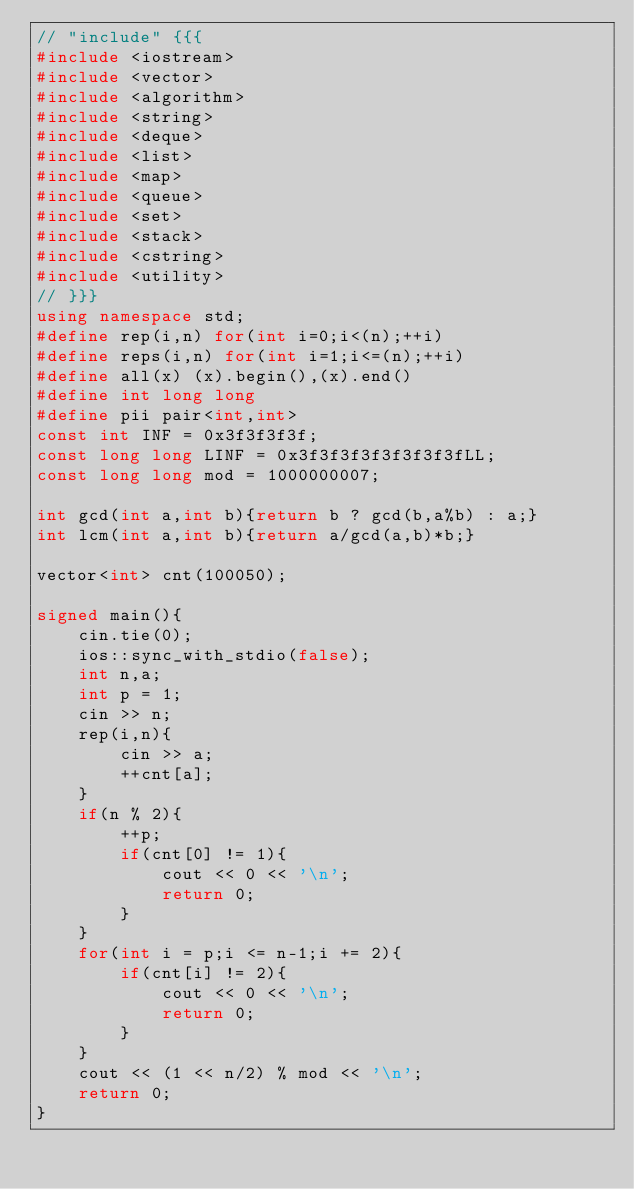<code> <loc_0><loc_0><loc_500><loc_500><_C++_>// "include" {{{
#include <iostream>
#include <vector>
#include <algorithm>
#include <string>
#include <deque>
#include <list>
#include <map>
#include <queue>
#include <set>
#include <stack>
#include <cstring>
#include <utility>
// }}}
using namespace std;
#define rep(i,n) for(int i=0;i<(n);++i)
#define reps(i,n) for(int i=1;i<=(n);++i)
#define all(x) (x).begin(),(x).end()
#define int long long 
#define pii pair<int,int> 
const int INF = 0x3f3f3f3f;
const long long LINF = 0x3f3f3f3f3f3f3f3fLL;
const long long mod = 1000000007;

int gcd(int a,int b){return b ? gcd(b,a%b) : a;}
int lcm(int a,int b){return a/gcd(a,b)*b;}

vector<int> cnt(100050);

signed main(){
    cin.tie(0);
	ios::sync_with_stdio(false);
	int n,a;
	int p = 1;
	cin >> n;
	rep(i,n){
		cin >> a;
		++cnt[a];
	}
	if(n % 2){
		++p;
		if(cnt[0] != 1){
			cout << 0 << '\n';
			return 0;
		}
	}
	for(int i = p;i <= n-1;i += 2){
		if(cnt[i] != 2){
			cout << 0 << '\n';
			return 0;
		}
	}
	cout << (1 << n/2) % mod << '\n';
	return 0;
}
</code> 